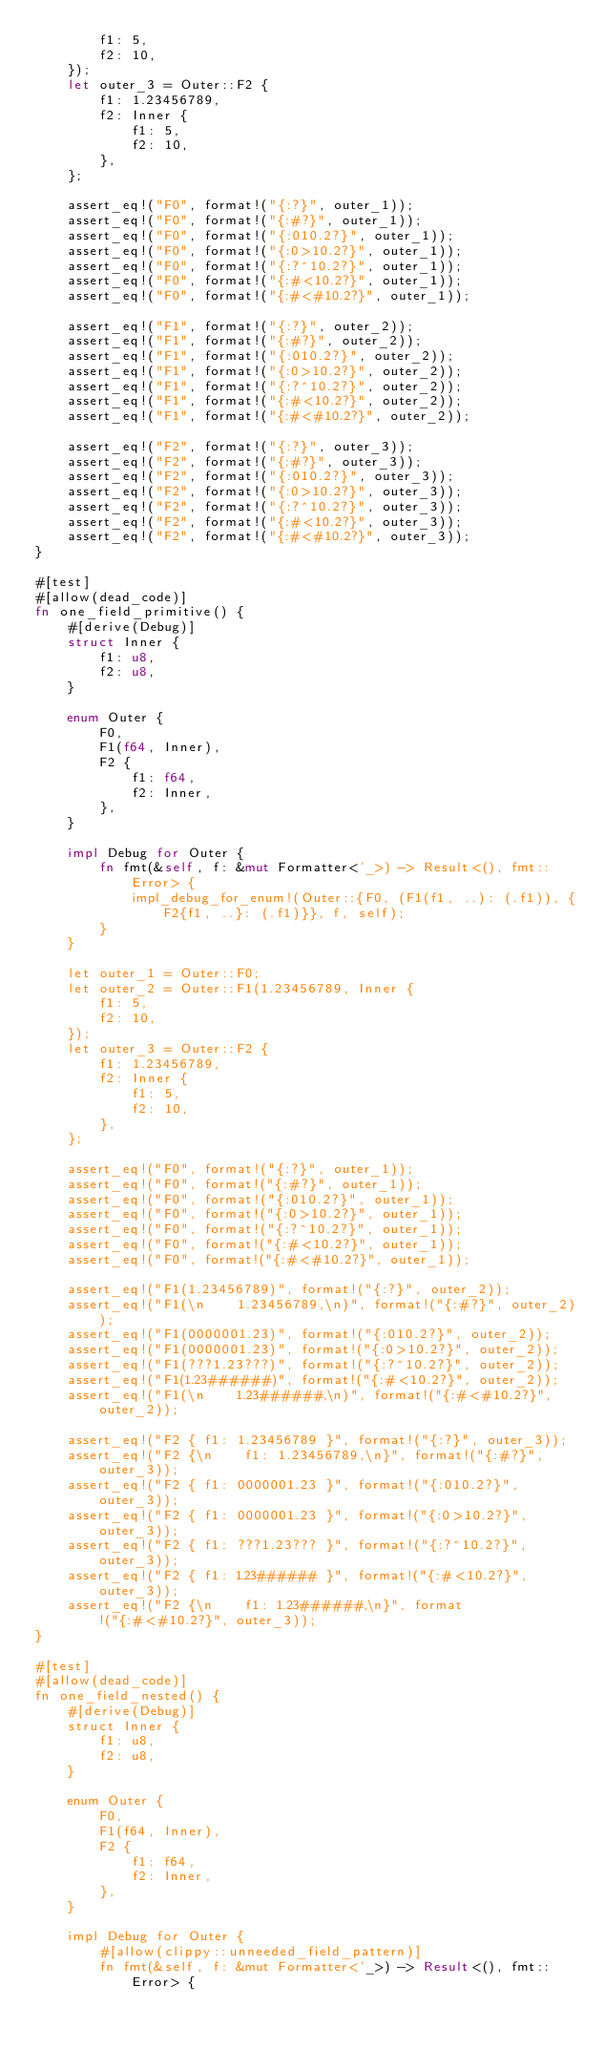<code> <loc_0><loc_0><loc_500><loc_500><_Rust_>        f1: 5,
        f2: 10,
    });
    let outer_3 = Outer::F2 {
        f1: 1.23456789,
        f2: Inner {
            f1: 5,
            f2: 10,
        },
    };

    assert_eq!("F0", format!("{:?}", outer_1));
    assert_eq!("F0", format!("{:#?}", outer_1));
    assert_eq!("F0", format!("{:010.2?}", outer_1));
    assert_eq!("F0", format!("{:0>10.2?}", outer_1));
    assert_eq!("F0", format!("{:?^10.2?}", outer_1));
    assert_eq!("F0", format!("{:#<10.2?}", outer_1));
    assert_eq!("F0", format!("{:#<#10.2?}", outer_1));

    assert_eq!("F1", format!("{:?}", outer_2));
    assert_eq!("F1", format!("{:#?}", outer_2));
    assert_eq!("F1", format!("{:010.2?}", outer_2));
    assert_eq!("F1", format!("{:0>10.2?}", outer_2));
    assert_eq!("F1", format!("{:?^10.2?}", outer_2));
    assert_eq!("F1", format!("{:#<10.2?}", outer_2));
    assert_eq!("F1", format!("{:#<#10.2?}", outer_2));

    assert_eq!("F2", format!("{:?}", outer_3));
    assert_eq!("F2", format!("{:#?}", outer_3));
    assert_eq!("F2", format!("{:010.2?}", outer_3));
    assert_eq!("F2", format!("{:0>10.2?}", outer_3));
    assert_eq!("F2", format!("{:?^10.2?}", outer_3));
    assert_eq!("F2", format!("{:#<10.2?}", outer_3));
    assert_eq!("F2", format!("{:#<#10.2?}", outer_3));
}

#[test]
#[allow(dead_code)]
fn one_field_primitive() {
    #[derive(Debug)]
    struct Inner {
        f1: u8,
        f2: u8,
    }

    enum Outer {
        F0,
        F1(f64, Inner),
        F2 {
            f1: f64,
            f2: Inner,
        },
    }

    impl Debug for Outer {
        fn fmt(&self, f: &mut Formatter<'_>) -> Result<(), fmt::Error> {
            impl_debug_for_enum!(Outer::{F0, (F1(f1, ..): (.f1)), {F2{f1, ..}: (.f1)}}, f, self);
        }
    }

    let outer_1 = Outer::F0;
    let outer_2 = Outer::F1(1.23456789, Inner {
        f1: 5,
        f2: 10,
    });
    let outer_3 = Outer::F2 {
        f1: 1.23456789,
        f2: Inner {
            f1: 5,
            f2: 10,
        },
    };

    assert_eq!("F0", format!("{:?}", outer_1));
    assert_eq!("F0", format!("{:#?}", outer_1));
    assert_eq!("F0", format!("{:010.2?}", outer_1));
    assert_eq!("F0", format!("{:0>10.2?}", outer_1));
    assert_eq!("F0", format!("{:?^10.2?}", outer_1));
    assert_eq!("F0", format!("{:#<10.2?}", outer_1));
    assert_eq!("F0", format!("{:#<#10.2?}", outer_1));

    assert_eq!("F1(1.23456789)", format!("{:?}", outer_2));
    assert_eq!("F1(\n    1.23456789,\n)", format!("{:#?}", outer_2));
    assert_eq!("F1(0000001.23)", format!("{:010.2?}", outer_2));
    assert_eq!("F1(0000001.23)", format!("{:0>10.2?}", outer_2));
    assert_eq!("F1(???1.23???)", format!("{:?^10.2?}", outer_2));
    assert_eq!("F1(1.23######)", format!("{:#<10.2?}", outer_2));
    assert_eq!("F1(\n    1.23######,\n)", format!("{:#<#10.2?}", outer_2));

    assert_eq!("F2 { f1: 1.23456789 }", format!("{:?}", outer_3));
    assert_eq!("F2 {\n    f1: 1.23456789,\n}", format!("{:#?}", outer_3));
    assert_eq!("F2 { f1: 0000001.23 }", format!("{:010.2?}", outer_3));
    assert_eq!("F2 { f1: 0000001.23 }", format!("{:0>10.2?}", outer_3));
    assert_eq!("F2 { f1: ???1.23??? }", format!("{:?^10.2?}", outer_3));
    assert_eq!("F2 { f1: 1.23###### }", format!("{:#<10.2?}", outer_3));
    assert_eq!("F2 {\n    f1: 1.23######,\n}", format!("{:#<#10.2?}", outer_3));
}

#[test]
#[allow(dead_code)]
fn one_field_nested() {
    #[derive(Debug)]
    struct Inner {
        f1: u8,
        f2: u8,
    }

    enum Outer {
        F0,
        F1(f64, Inner),
        F2 {
            f1: f64,
            f2: Inner,
        },
    }

    impl Debug for Outer {
        #[allow(clippy::unneeded_field_pattern)]
        fn fmt(&self, f: &mut Formatter<'_>) -> Result<(), fmt::Error> {</code> 